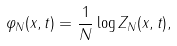<formula> <loc_0><loc_0><loc_500><loc_500>\varphi _ { N } ( x , t ) = \frac { 1 } { N } \log Z _ { N } ( x , t ) ,</formula> 